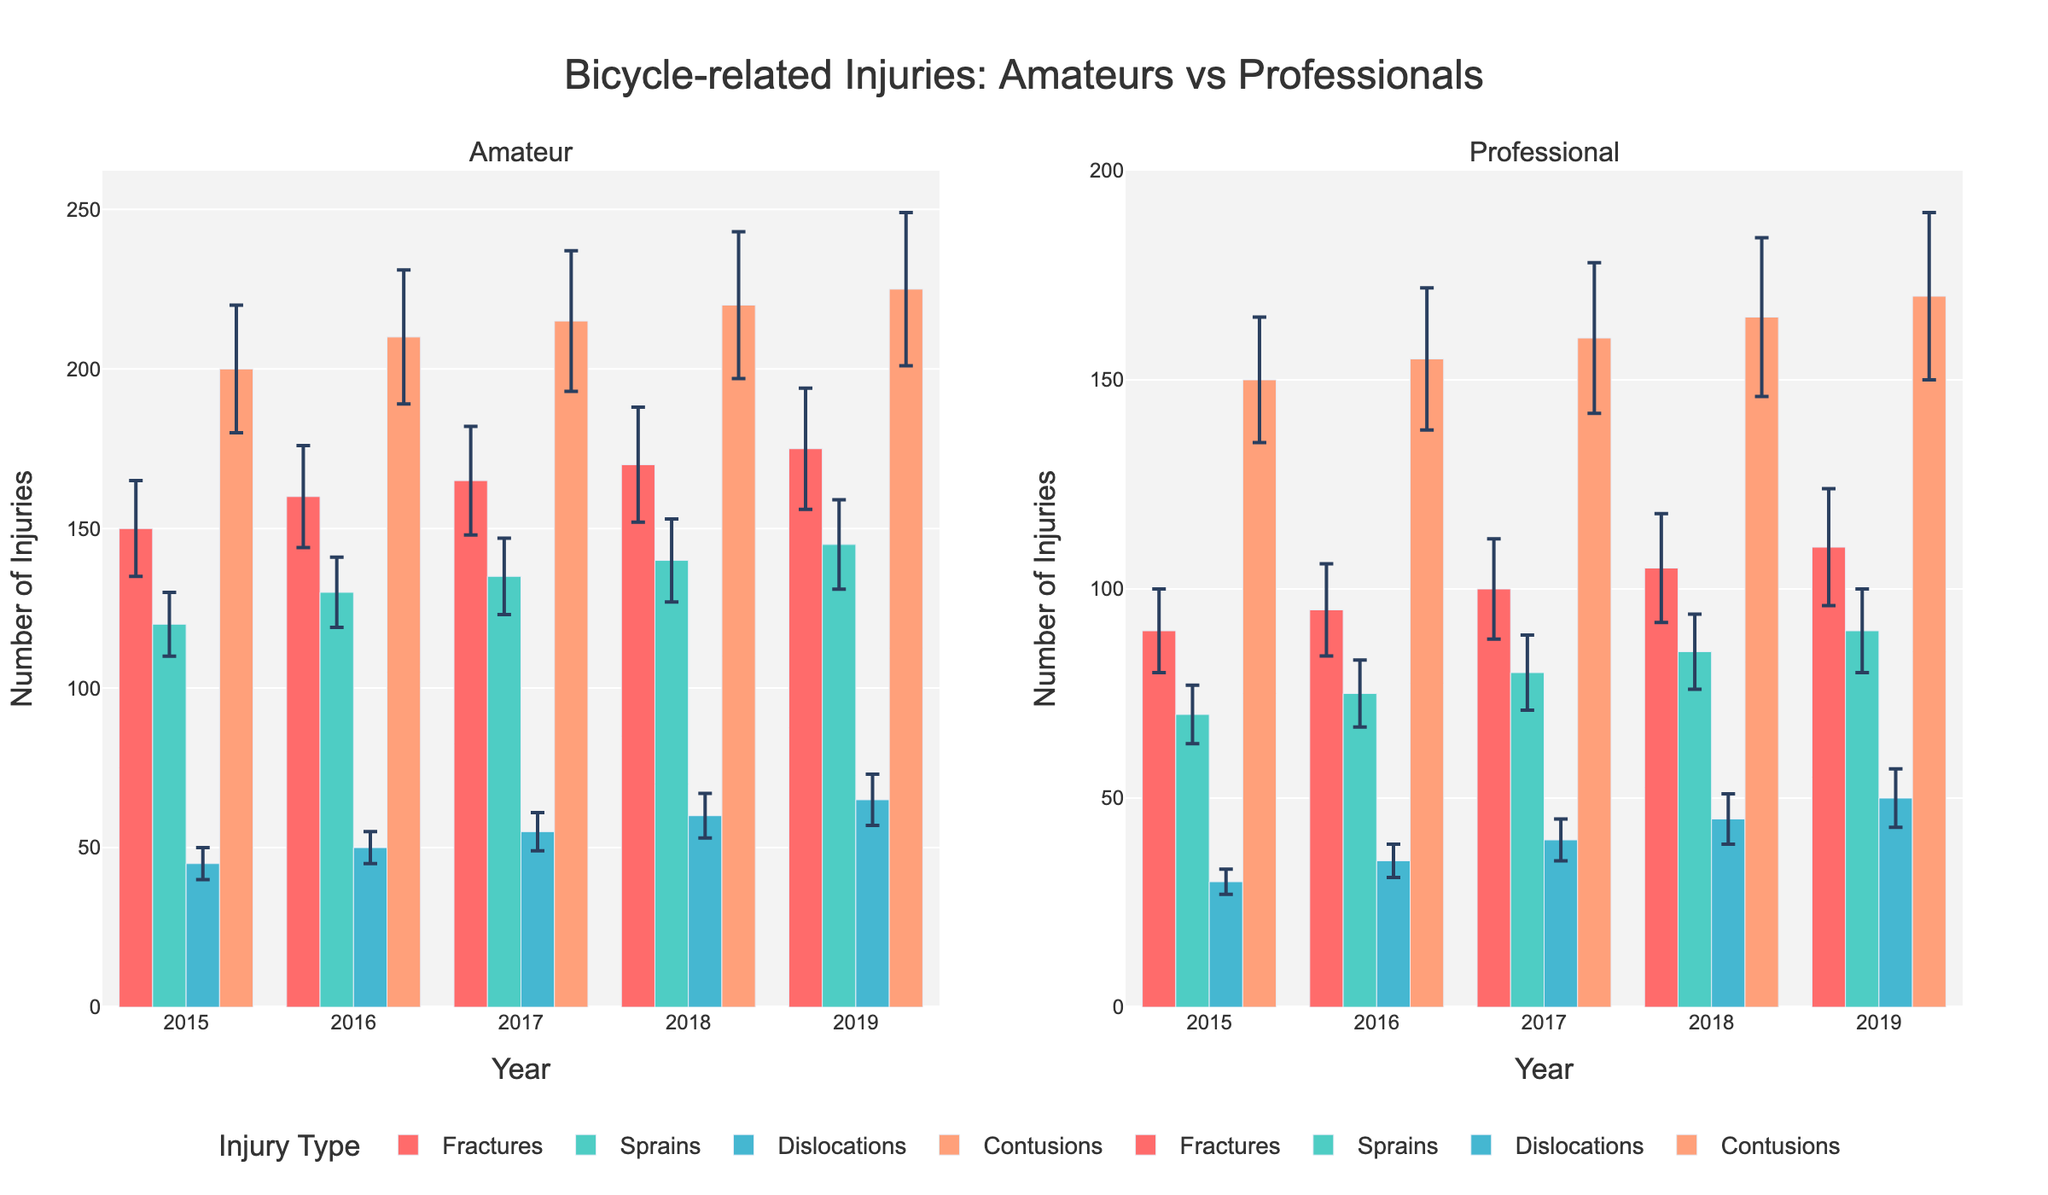What is the total number of contusion injuries among amateurs in 2018? According to the figure, the frequency of contusion injuries for amateurs in 2018 is indicated by the bar's height, which is 220.
Answer: 220 Which year recorded the highest number of fractures among professionals? By inspecting the bars representing fractures among professionals across the years, we can see that 2019 has the highest bar for fractures at 110.
Answer: 2019 How does the number of sprain injuries in 2016 among amateurs compare to 2017? Comparing the heights of the bars for sprains among amateurs in 2016 (130) and 2017 (135) shows that 2017 has slightly more sprain injuries than 2016.
Answer: 2017 has more What is the average number of dislocation injuries among professionals from 2015 to 2019? To find the average, sum the frequencies of dislocations among professionals (30+35+40+45+50) and divide by the number of years (5). The total is 200, so the average is 200/5 = 40.
Answer: 40 Which type of injury has the largest increase in frequency among amateurs from 2015 to 2019? By examining the change in bar heights from 2015 to 2019 for amateurs: Fractures (175-150 = 25), Sprains (145-120 = 25), Dislocations (65-45 = 20), and Contusions (225-200 = 25). All show an increase of 25 for fractures, sprains, and contusions.
Answer: Fractures, Sprains, Contusions In 2017, which category (amateurs or professionals) reported a higher number of total injuries for all types combined? Summing all injury types for 2017 for amateurs: Fractures (165) + Sprains (135) + Dislocations (55) + Contusions (215) = 570. For professionals: Fractures (100) + Sprains (80) + Dislocations (40) + Contusions (160) = 380. Amateurs have higher total injuries.
Answer: Amateurs What is the median number of contusions among amateurs from 2015 to 2019? The frequencies of contusions among amateurs are 200, 210, 215, 220, 225. Arranged in ascending order, the median is the middle value, which is 215.
Answer: 215 How does the error margin for fractures among professionals in 2019 compare to that in 2015? The error margin for fractures among professionals in 2019 is 14, and in 2015 it is 10. Therefore, the error margin increased by 4.
Answer: Increased What was the highest frequency of injuries among professionals across all years? By inspecting the highest points across all bars for professionals, the highest frequency is the 170 injuries for contusions in 2019.
Answer: 170 Which category and year had the lowest frequency of dislocation injuries? By examining the bars representing dislocations for both amateurs and professionals, the lowest is for professionals in 2015 with a frequency of 30.
Answer: Professionals, 2015 